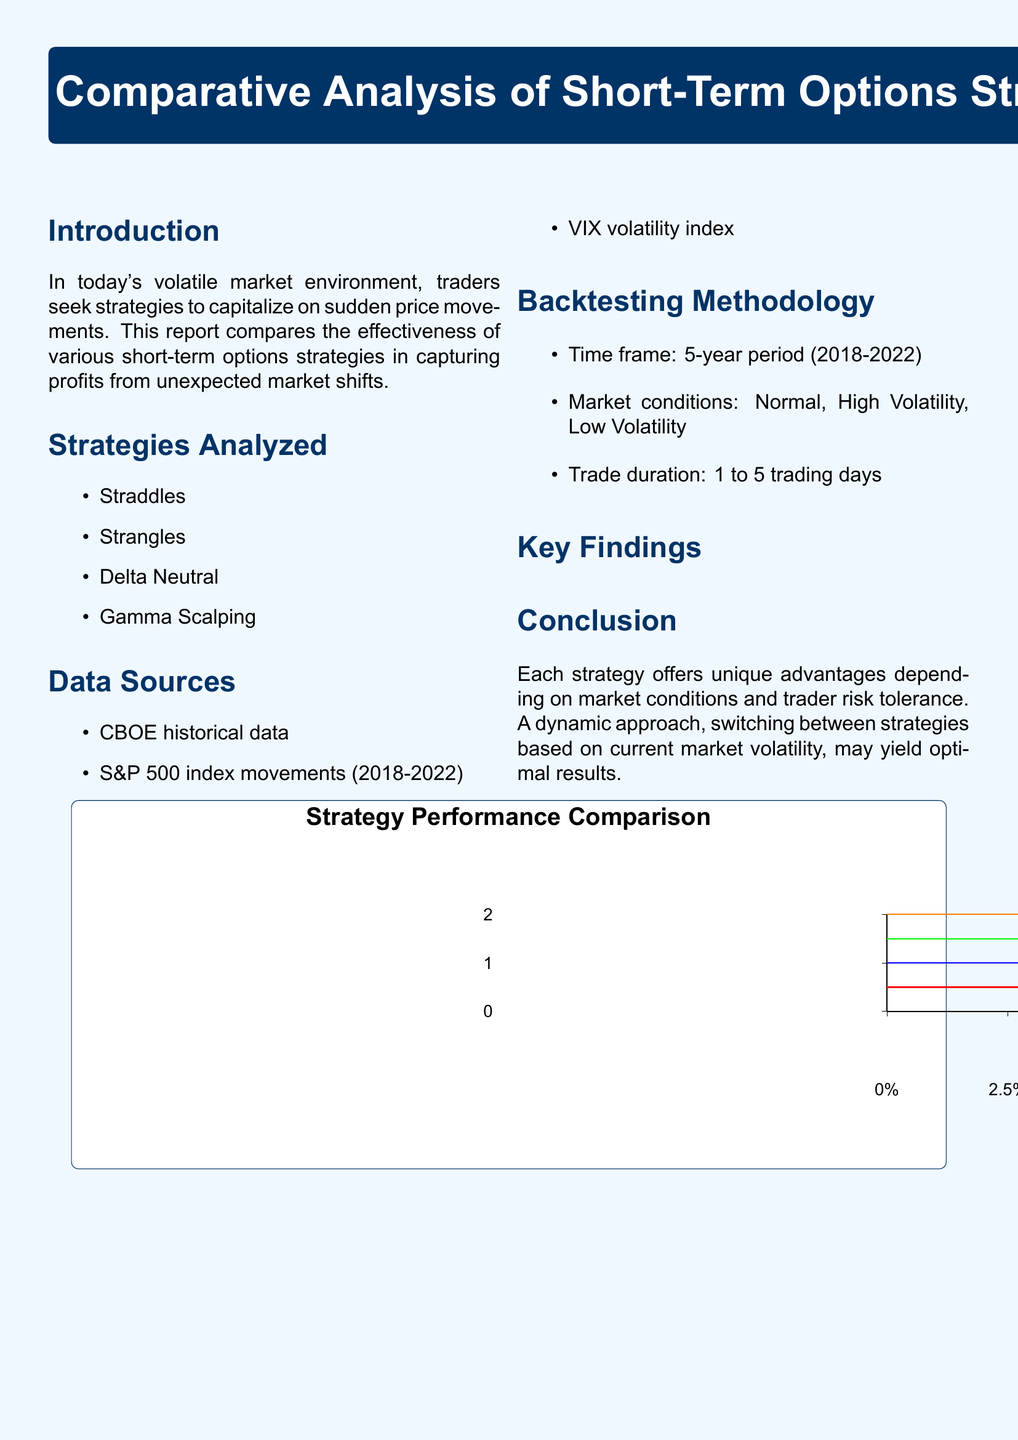what is the title of the report? The title of the report appears prominently at the beginning and is, "Comparative Analysis of Short-Term Options Strategies for Sudden Market Movements."
Answer: Comparative Analysis of Short-Term Options Strategies for Sudden Market Movements what time frame was used for backtesting? The backtesting was conducted over a specific duration mentioned in the methodology section, which is a 5-year period.
Answer: 5-year period (2018-2022) which strategy has the highest average return? The key findings indicate that Gamma Scalping has the highest average return among the analyzed strategies.
Answer: 10.1% per trade what is the risk profile of Straddles? The risk profile for the Straddles strategy is provided in the table of key findings.
Answer: High what market condition did Straddles perform best in? The performance details for Straddles indicate it is most effective during high volatility periods.
Answer: High volatility which data source covers volatility? The document lists several data sources, one of which specifically relates to volatility.
Answer: VIX volatility index what is the recommendation made in the conclusion? The conclusion section provides a strategic suggestion regarding trading approaches based on volatility.
Answer: A dynamic approach, switching between strategies based on current market volatility, may yield optimal results which strategy is described as requiring active management? The findings indicate that one strategy stands out for needing active management amidst the others.
Answer: Gamma Scalping 